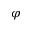Convert formula to latex. <formula><loc_0><loc_0><loc_500><loc_500>\varphi</formula> 